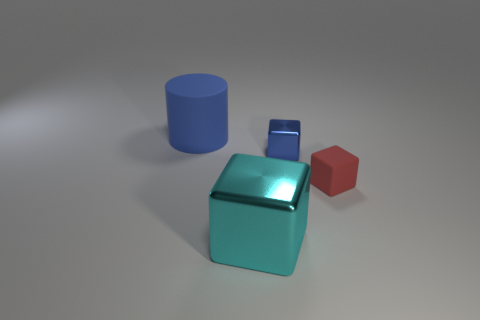Subtract all shiny blocks. How many blocks are left? 1 Subtract all blue cubes. How many cubes are left? 2 Subtract all cubes. How many objects are left? 1 Add 2 big matte objects. How many big matte objects exist? 3 Add 2 big blue rubber cylinders. How many objects exist? 6 Subtract 0 purple spheres. How many objects are left? 4 Subtract all blue blocks. Subtract all brown balls. How many blocks are left? 2 Subtract all big cyan objects. Subtract all big shiny objects. How many objects are left? 2 Add 4 cubes. How many cubes are left? 7 